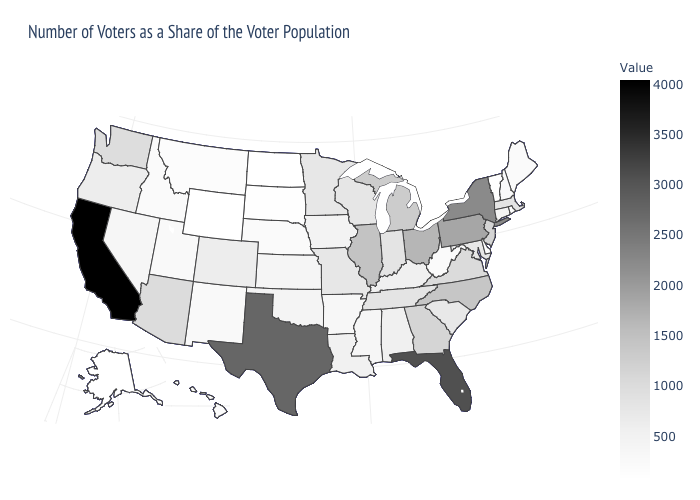Does New York have the lowest value in the Northeast?
Quick response, please. No. Does Georgia have a lower value than Texas?
Give a very brief answer. Yes. 